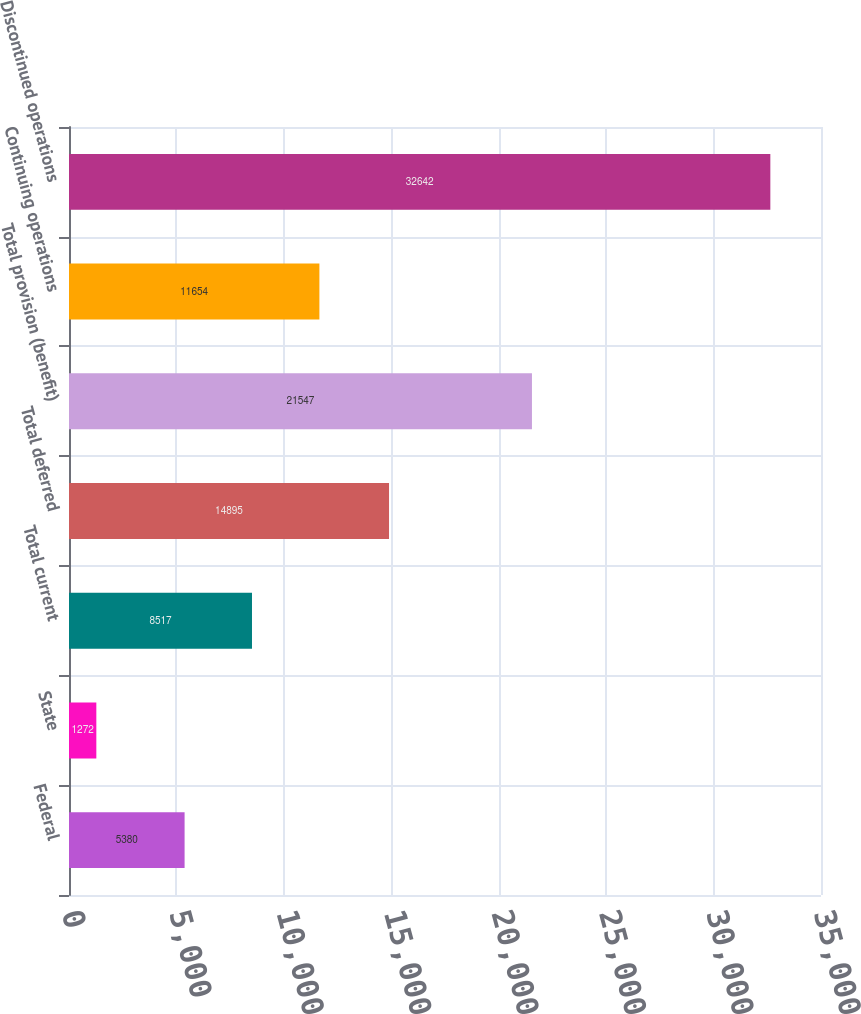<chart> <loc_0><loc_0><loc_500><loc_500><bar_chart><fcel>Federal<fcel>State<fcel>Total current<fcel>Total deferred<fcel>Total provision (benefit)<fcel>Continuing operations<fcel>Discontinued operations<nl><fcel>5380<fcel>1272<fcel>8517<fcel>14895<fcel>21547<fcel>11654<fcel>32642<nl></chart> 